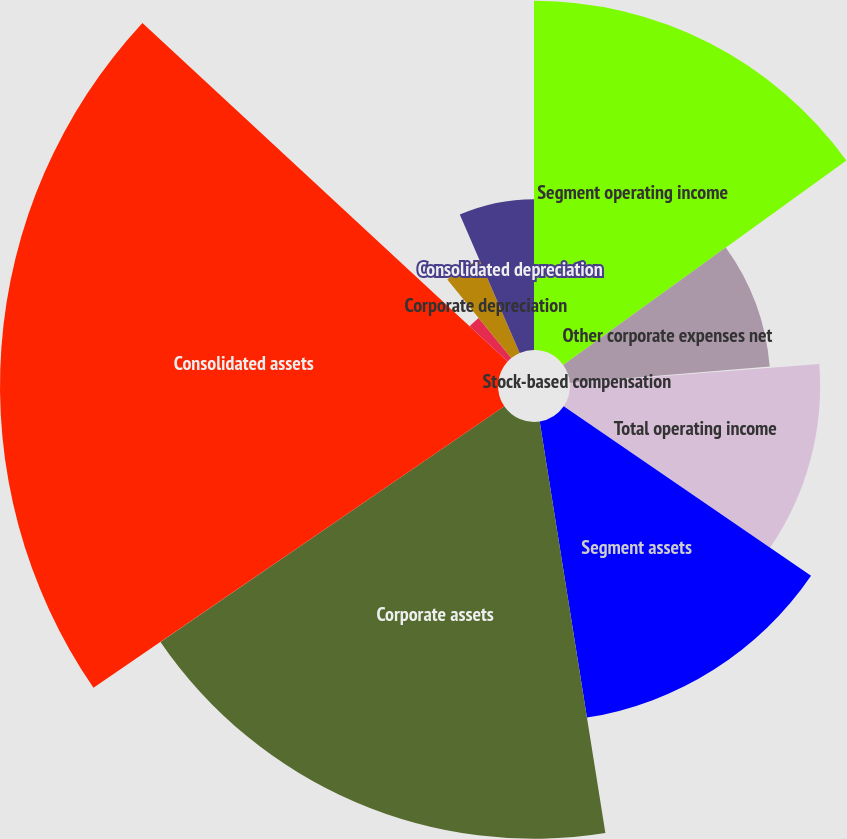Convert chart. <chart><loc_0><loc_0><loc_500><loc_500><pie_chart><fcel>Segment operating income<fcel>Other corporate expenses net<fcel>Stock-based compensation<fcel>Total operating income<fcel>Segment assets<fcel>Corporate assets<fcel>Consolidated assets<fcel>Segment depreciation<fcel>Corporate depreciation<fcel>Consolidated depreciation<nl><fcel>15.05%<fcel>8.64%<fcel>0.09%<fcel>10.78%<fcel>12.92%<fcel>17.96%<fcel>21.46%<fcel>2.23%<fcel>4.37%<fcel>6.5%<nl></chart> 